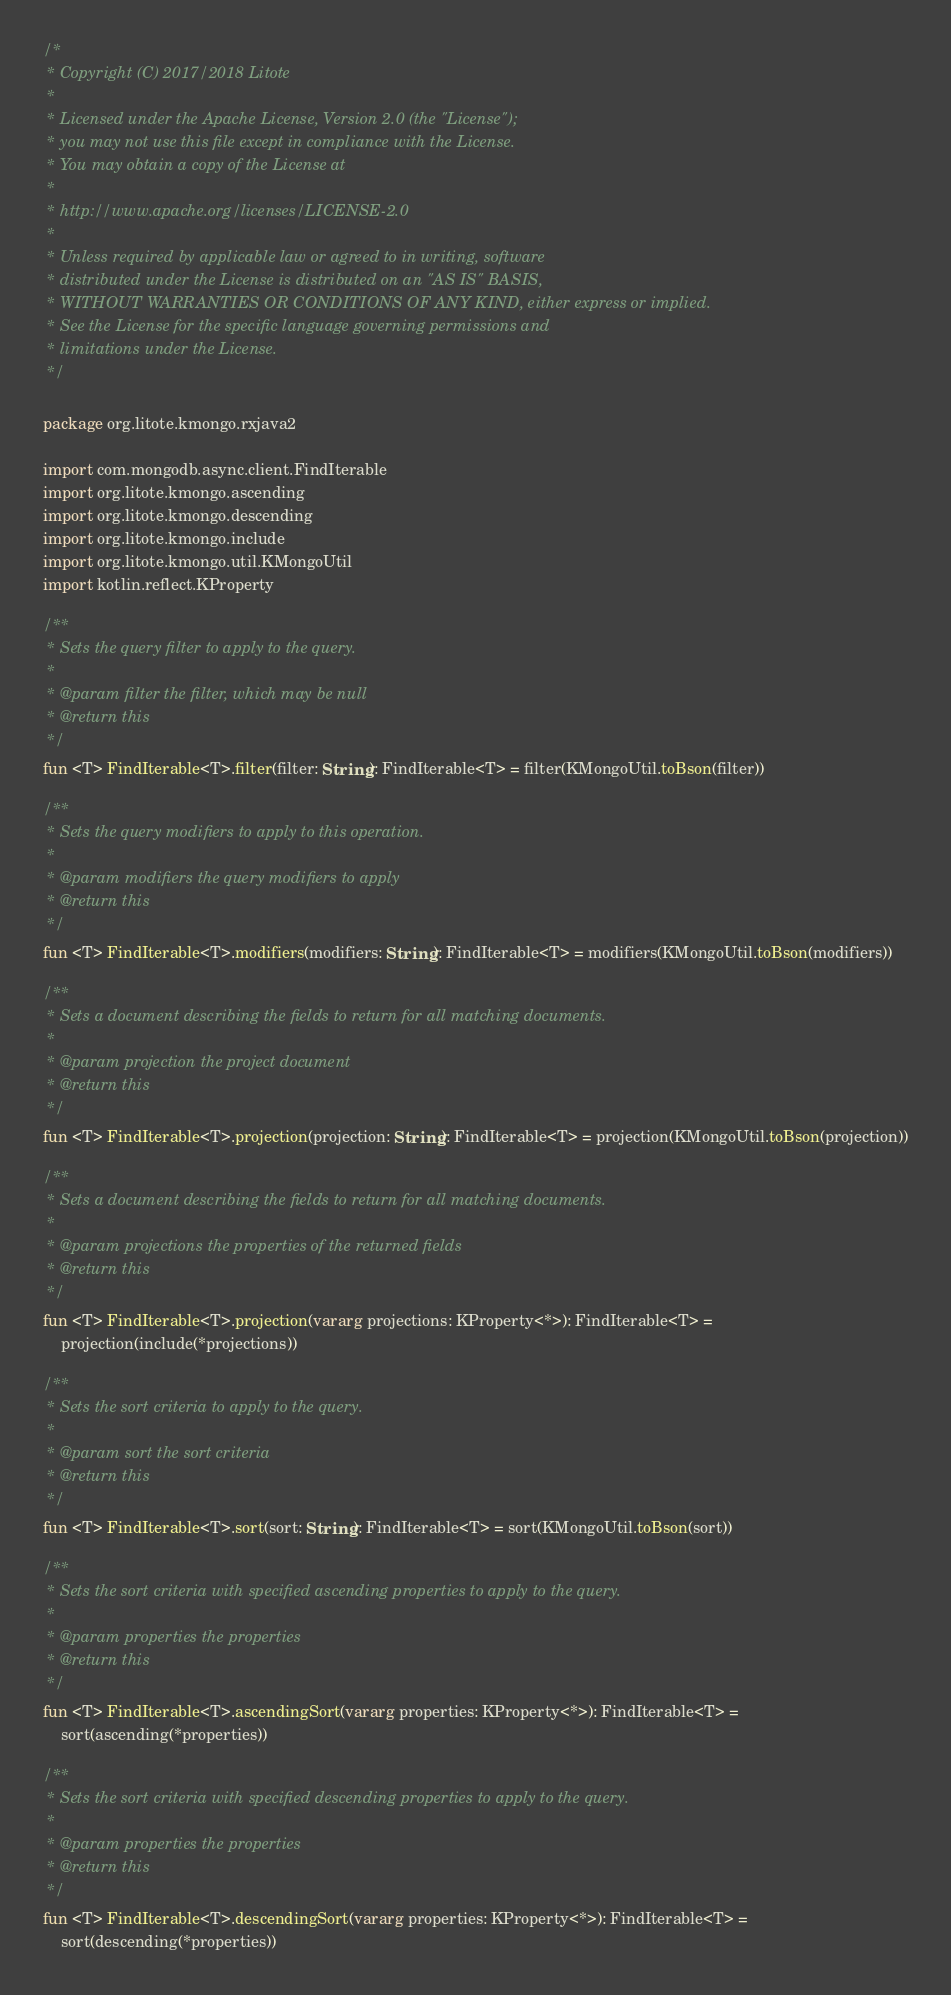Convert code to text. <code><loc_0><loc_0><loc_500><loc_500><_Kotlin_>/*
 * Copyright (C) 2017/2018 Litote
 *
 * Licensed under the Apache License, Version 2.0 (the "License");
 * you may not use this file except in compliance with the License.
 * You may obtain a copy of the License at
 *
 * http://www.apache.org/licenses/LICENSE-2.0
 *
 * Unless required by applicable law or agreed to in writing, software
 * distributed under the License is distributed on an "AS IS" BASIS,
 * WITHOUT WARRANTIES OR CONDITIONS OF ANY KIND, either express or implied.
 * See the License for the specific language governing permissions and
 * limitations under the License.
 */

package org.litote.kmongo.rxjava2

import com.mongodb.async.client.FindIterable
import org.litote.kmongo.ascending
import org.litote.kmongo.descending
import org.litote.kmongo.include
import org.litote.kmongo.util.KMongoUtil
import kotlin.reflect.KProperty

/**
 * Sets the query filter to apply to the query.
 *
 * @param filter the filter, which may be null
 * @return this
 */
fun <T> FindIterable<T>.filter(filter: String): FindIterable<T> = filter(KMongoUtil.toBson(filter))

/**
 * Sets the query modifiers to apply to this operation.
 *
 * @param modifiers the query modifiers to apply
 * @return this
 */
fun <T> FindIterable<T>.modifiers(modifiers: String): FindIterable<T> = modifiers(KMongoUtil.toBson(modifiers))

/**
 * Sets a document describing the fields to return for all matching documents.
 *
 * @param projection the project document
 * @return this
 */
fun <T> FindIterable<T>.projection(projection: String): FindIterable<T> = projection(KMongoUtil.toBson(projection))

/**
 * Sets a document describing the fields to return for all matching documents.
 *
 * @param projections the properties of the returned fields
 * @return this
 */
fun <T> FindIterable<T>.projection(vararg projections: KProperty<*>): FindIterable<T> =
    projection(include(*projections))

/**
 * Sets the sort criteria to apply to the query.
 *
 * @param sort the sort criteria
 * @return this
 */
fun <T> FindIterable<T>.sort(sort: String): FindIterable<T> = sort(KMongoUtil.toBson(sort))

/**
 * Sets the sort criteria with specified ascending properties to apply to the query.
 *
 * @param properties the properties
 * @return this
 */
fun <T> FindIterable<T>.ascendingSort(vararg properties: KProperty<*>): FindIterable<T> =
    sort(ascending(*properties))

/**
 * Sets the sort criteria with specified descending properties to apply to the query.
 *
 * @param properties the properties
 * @return this
 */
fun <T> FindIterable<T>.descendingSort(vararg properties: KProperty<*>): FindIterable<T> =
    sort(descending(*properties))
</code> 